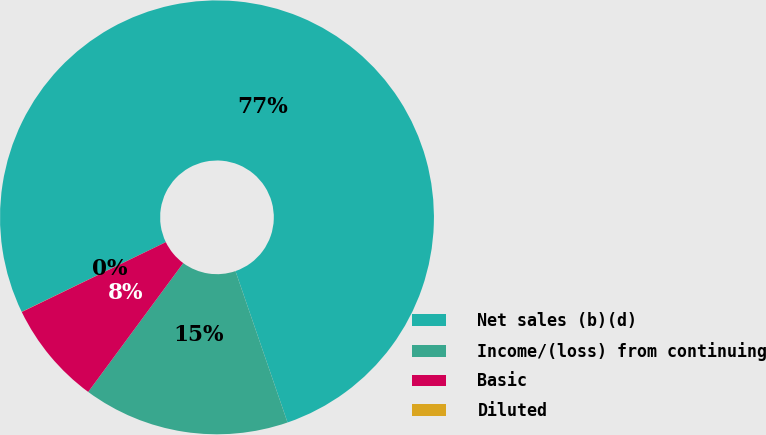Convert chart to OTSL. <chart><loc_0><loc_0><loc_500><loc_500><pie_chart><fcel>Net sales (b)(d)<fcel>Income/(loss) from continuing<fcel>Basic<fcel>Diluted<nl><fcel>76.91%<fcel>15.39%<fcel>7.7%<fcel>0.01%<nl></chart> 